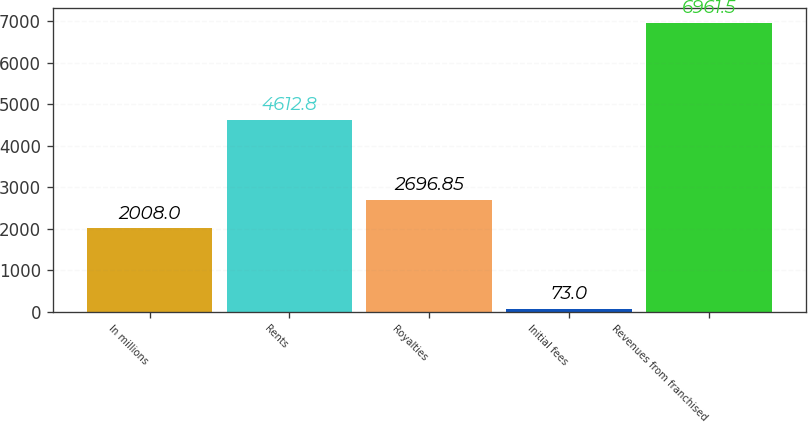<chart> <loc_0><loc_0><loc_500><loc_500><bar_chart><fcel>In millions<fcel>Rents<fcel>Royalties<fcel>Initial fees<fcel>Revenues from franchised<nl><fcel>2008<fcel>4612.8<fcel>2696.85<fcel>73<fcel>6961.5<nl></chart> 